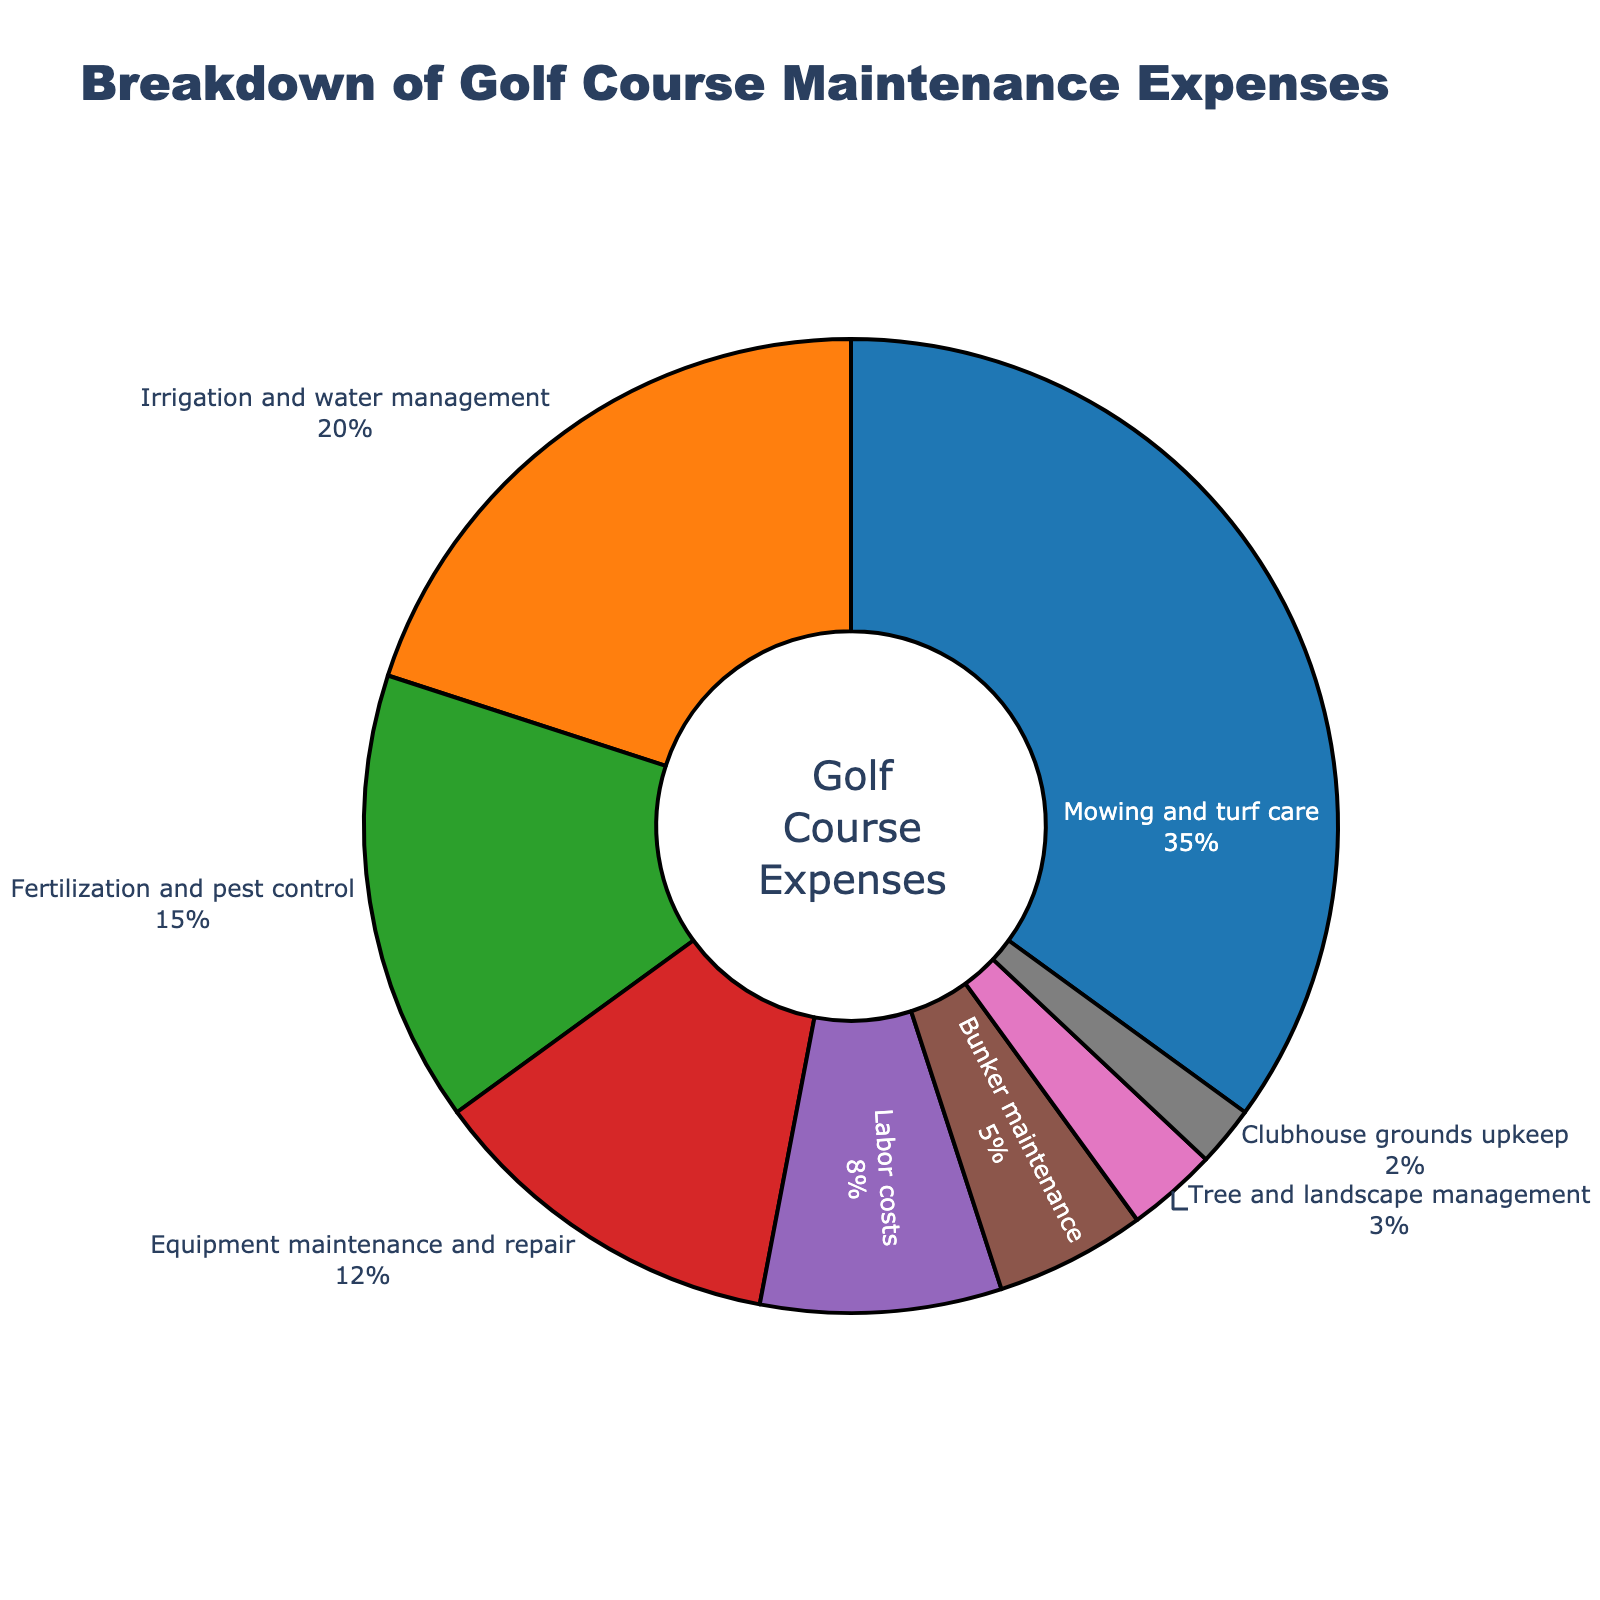What percentage of the expenses go towards bunker maintenance and labor costs combined? Bunker maintenance is 5%, and labor costs are 8%. Adding them together (5% + 8%) yields 13%.
Answer: 13% Which category takes up the largest portion of the expenses? The largest portion of the expenses (35%) is allocated to mowing and turf care.
Answer: Mowing and turf care Is more money spent on irrigation and water management or tree and landscape management? Irrigation and water management is 20%, while tree and landscape management is 3%. 20% is greater than 3%.
Answer: Irrigation and water management What is the smallest expense category, and what percentage does it represent? The smallest expense category is clubhouse grounds upkeep, which accounts for 2% of the expenses.
Answer: Clubhouse grounds upkeep, 2% By how much does the spending on fertilization and pest control exceed that on tree and landscape management? Fertilization and pest control is 15%, and tree and landscape management is 3%. The difference is 15% - 3% = 12%.
Answer: 12% What's the total percentage of expenses that go towards mowing and turf care, and irrigation and water management? Mowing and turf care is 35%, and irrigation and water management is 20%. Adding them together (35% + 20%) results in 55%.
Answer: 55% Compare the expenditures on labor costs and equipment maintenance and repair. Which is higher, and by how much? Equipment maintenance and repair is 12%, while labor costs are 8%. The difference is 12% - 8% = 4%.
Answer: Equipment maintenance and repair, by 4% What is the combined percentage of all the categories not related to water and turf care (excluding mowing and turf care and irrigation and water management)? The categories not related to water and turf care are fertilization and pest control (15%), equipment maintenance and repair (12%), labor costs (8%), bunker maintenance (5%), tree and landscape management (3%), and clubhouse grounds upkeep (2%). Adding them together: 15% + 12% + 8% + 5% + 3% + 2% = 45%.
Answer: 45% Which two categories have the closest expense percentages, and what are their percentages? Labor costs (8%) and bunker maintenance (5%) have the closest percentages with a difference of only 3%.
Answer: Labor costs (8%) and bunker maintenance (5%) What percentage of the expenses is allocated to both equipment maintenance and repair and fertilization and pest control combined? Equipment maintenance and repair is 12%, and fertilization and pest control is 15%. Adding them together (12% + 15%) yields 27%.
Answer: 27% 